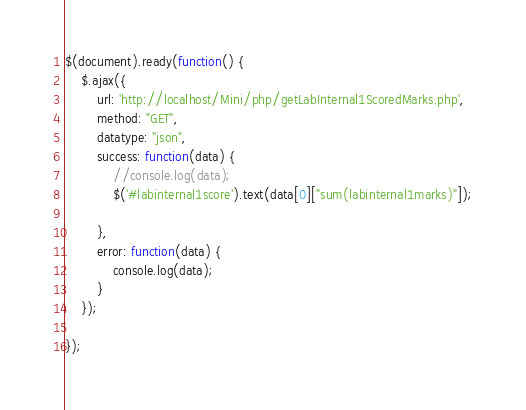<code> <loc_0><loc_0><loc_500><loc_500><_JavaScript_>$(document).ready(function() {
    $.ajax({
        url: 'http://localhost/Mini/php/getLabInternal1ScoredMarks.php',
        method: "GET",
        datatype: "json",
        success: function(data) {
            //console.log(data);
            $('#labinternal1score').text(data[0]["sum(labinternal1marks)"]);

        },
        error: function(data) {
            console.log(data);
        }
    });

});</code> 